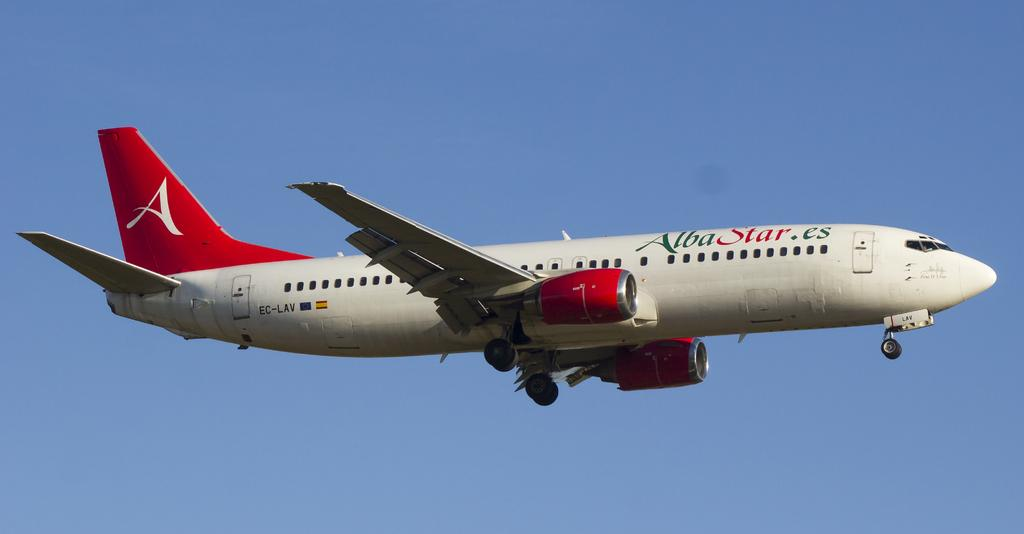What is the main subject of the image? The main subject of the image is an airplane. What is the airplane doing in the image? The airplane is flying in the air. What type of milk is being served on the airplane in the image? There is no milk or any reference to serving food or drinks in the image; it only shows an airplane flying in the air. 